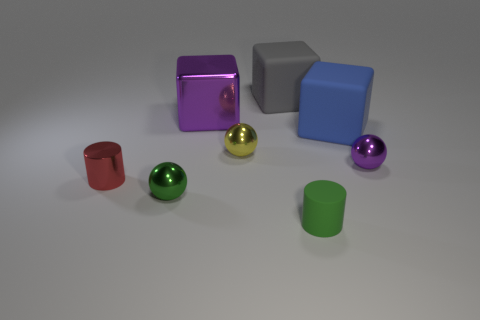Add 1 small metal spheres. How many objects exist? 9 Subtract all purple metallic balls. How many balls are left? 2 Subtract all green balls. How many balls are left? 2 Subtract all blue cylinders. Subtract all red blocks. How many cylinders are left? 2 Subtract all yellow cylinders. How many green spheres are left? 1 Subtract all rubber things. Subtract all yellow spheres. How many objects are left? 4 Add 4 large purple shiny cubes. How many large purple shiny cubes are left? 5 Add 8 small red metallic cylinders. How many small red metallic cylinders exist? 9 Subtract 1 blue blocks. How many objects are left? 7 Subtract all cylinders. How many objects are left? 6 